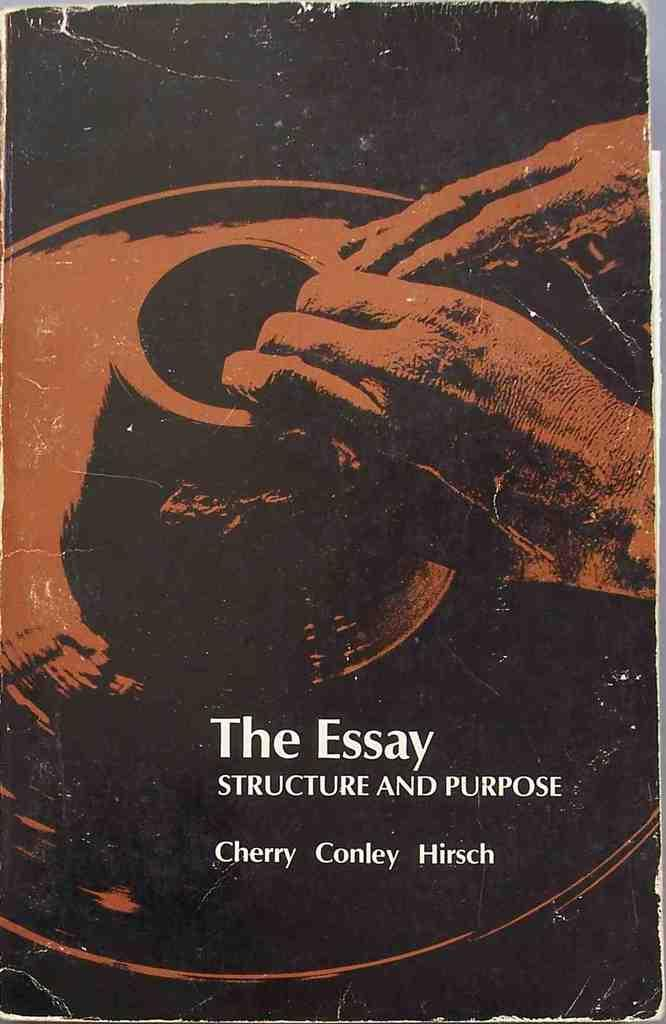Provide a one-sentence caption for the provided image. A close up of a book called the The Essay has a picture of a man sculpting clay on a potters wheel on its cover. 